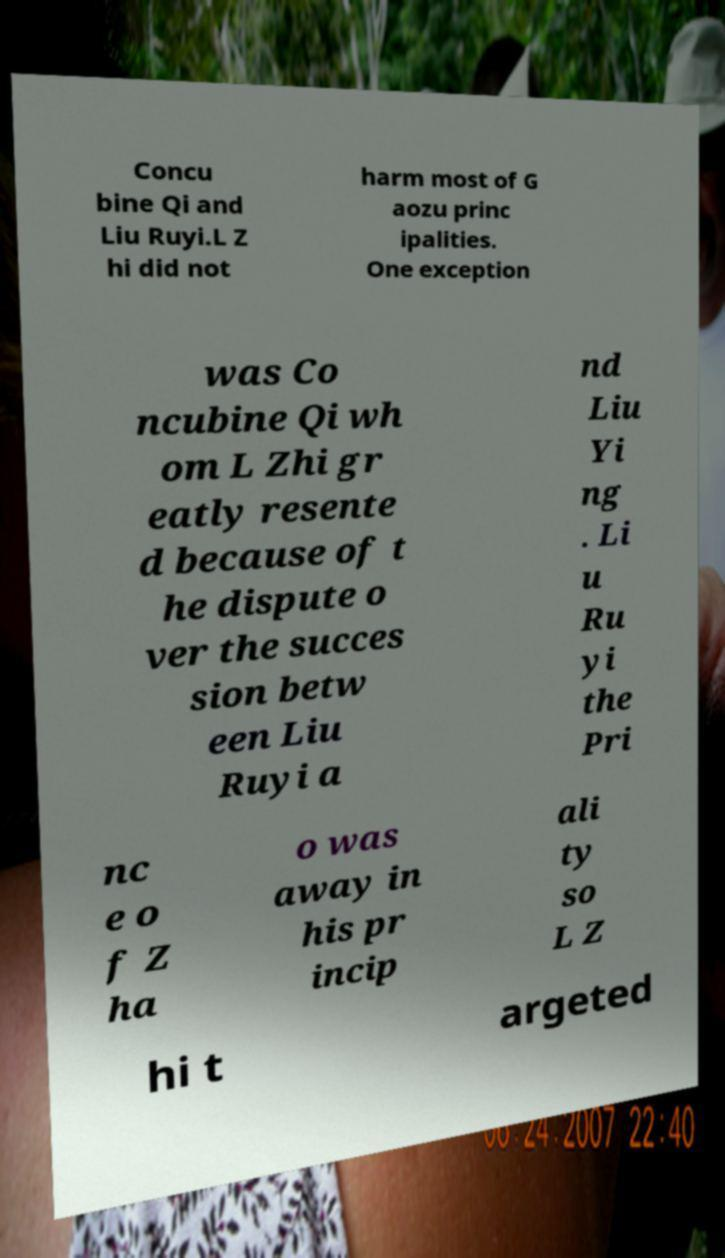There's text embedded in this image that I need extracted. Can you transcribe it verbatim? Concu bine Qi and Liu Ruyi.L Z hi did not harm most of G aozu princ ipalities. One exception was Co ncubine Qi wh om L Zhi gr eatly resente d because of t he dispute o ver the succes sion betw een Liu Ruyi a nd Liu Yi ng . Li u Ru yi the Pri nc e o f Z ha o was away in his pr incip ali ty so L Z hi t argeted 